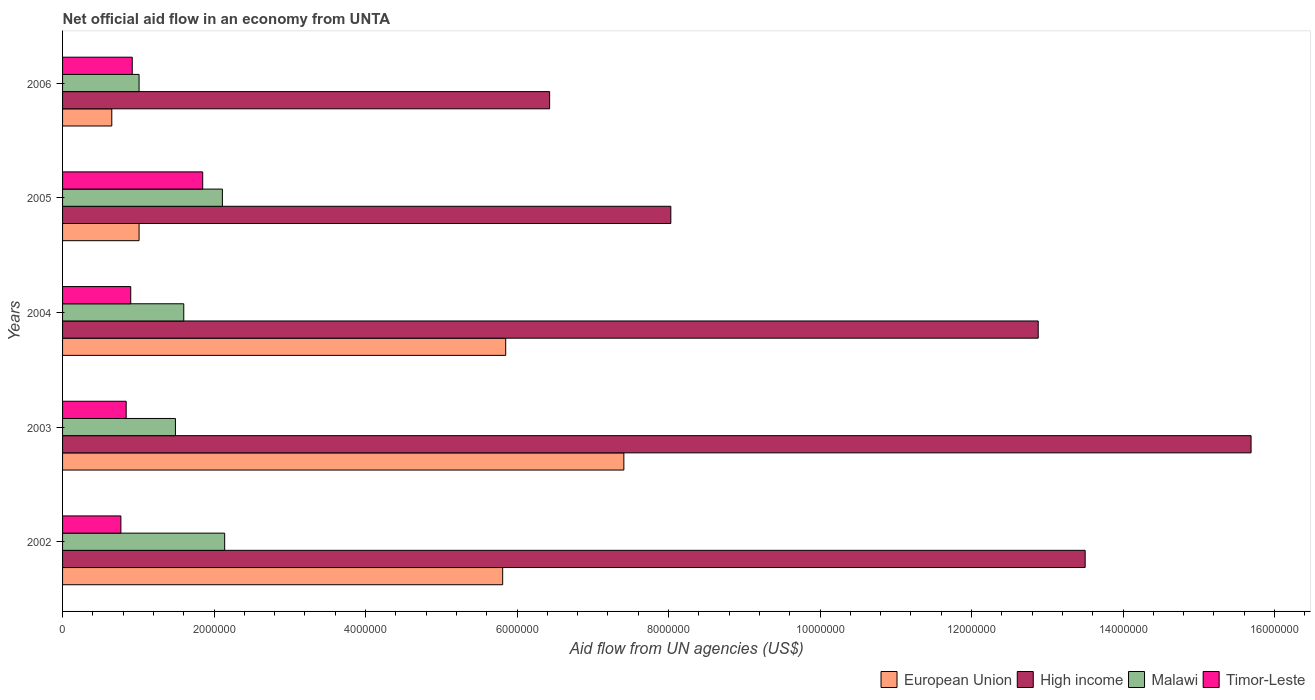How many groups of bars are there?
Make the answer very short. 5. How many bars are there on the 5th tick from the top?
Ensure brevity in your answer.  4. What is the label of the 5th group of bars from the top?
Provide a short and direct response. 2002. What is the net official aid flow in European Union in 2002?
Make the answer very short. 5.81e+06. Across all years, what is the maximum net official aid flow in Timor-Leste?
Ensure brevity in your answer.  1.85e+06. Across all years, what is the minimum net official aid flow in European Union?
Your response must be concise. 6.50e+05. What is the total net official aid flow in Timor-Leste in the graph?
Keep it short and to the point. 5.28e+06. What is the difference between the net official aid flow in European Union in 2002 and that in 2005?
Give a very brief answer. 4.80e+06. What is the difference between the net official aid flow in High income in 2005 and the net official aid flow in Malawi in 2002?
Provide a succinct answer. 5.89e+06. What is the average net official aid flow in High income per year?
Provide a succinct answer. 1.13e+07. In the year 2005, what is the difference between the net official aid flow in High income and net official aid flow in European Union?
Ensure brevity in your answer.  7.02e+06. What is the ratio of the net official aid flow in Malawi in 2003 to that in 2004?
Offer a very short reply. 0.93. Is the net official aid flow in Timor-Leste in 2003 less than that in 2005?
Your answer should be compact. Yes. What is the difference between the highest and the second highest net official aid flow in Timor-Leste?
Provide a short and direct response. 9.30e+05. What is the difference between the highest and the lowest net official aid flow in European Union?
Provide a succinct answer. 6.76e+06. In how many years, is the net official aid flow in High income greater than the average net official aid flow in High income taken over all years?
Give a very brief answer. 3. Is the sum of the net official aid flow in High income in 2002 and 2004 greater than the maximum net official aid flow in Malawi across all years?
Provide a succinct answer. Yes. Is it the case that in every year, the sum of the net official aid flow in High income and net official aid flow in Timor-Leste is greater than the net official aid flow in Malawi?
Your answer should be compact. Yes. Are the values on the major ticks of X-axis written in scientific E-notation?
Make the answer very short. No. What is the title of the graph?
Keep it short and to the point. Net official aid flow in an economy from UNTA. What is the label or title of the X-axis?
Your answer should be compact. Aid flow from UN agencies (US$). What is the Aid flow from UN agencies (US$) of European Union in 2002?
Give a very brief answer. 5.81e+06. What is the Aid flow from UN agencies (US$) of High income in 2002?
Provide a succinct answer. 1.35e+07. What is the Aid flow from UN agencies (US$) in Malawi in 2002?
Your response must be concise. 2.14e+06. What is the Aid flow from UN agencies (US$) of Timor-Leste in 2002?
Provide a succinct answer. 7.70e+05. What is the Aid flow from UN agencies (US$) in European Union in 2003?
Ensure brevity in your answer.  7.41e+06. What is the Aid flow from UN agencies (US$) in High income in 2003?
Your response must be concise. 1.57e+07. What is the Aid flow from UN agencies (US$) of Malawi in 2003?
Ensure brevity in your answer.  1.49e+06. What is the Aid flow from UN agencies (US$) in Timor-Leste in 2003?
Make the answer very short. 8.40e+05. What is the Aid flow from UN agencies (US$) in European Union in 2004?
Provide a short and direct response. 5.85e+06. What is the Aid flow from UN agencies (US$) of High income in 2004?
Give a very brief answer. 1.29e+07. What is the Aid flow from UN agencies (US$) of Malawi in 2004?
Make the answer very short. 1.60e+06. What is the Aid flow from UN agencies (US$) in Timor-Leste in 2004?
Offer a terse response. 9.00e+05. What is the Aid flow from UN agencies (US$) of European Union in 2005?
Provide a succinct answer. 1.01e+06. What is the Aid flow from UN agencies (US$) in High income in 2005?
Provide a short and direct response. 8.03e+06. What is the Aid flow from UN agencies (US$) of Malawi in 2005?
Provide a short and direct response. 2.11e+06. What is the Aid flow from UN agencies (US$) of Timor-Leste in 2005?
Your answer should be compact. 1.85e+06. What is the Aid flow from UN agencies (US$) of European Union in 2006?
Make the answer very short. 6.50e+05. What is the Aid flow from UN agencies (US$) in High income in 2006?
Provide a succinct answer. 6.43e+06. What is the Aid flow from UN agencies (US$) in Malawi in 2006?
Make the answer very short. 1.01e+06. What is the Aid flow from UN agencies (US$) in Timor-Leste in 2006?
Offer a very short reply. 9.20e+05. Across all years, what is the maximum Aid flow from UN agencies (US$) in European Union?
Your answer should be compact. 7.41e+06. Across all years, what is the maximum Aid flow from UN agencies (US$) of High income?
Provide a succinct answer. 1.57e+07. Across all years, what is the maximum Aid flow from UN agencies (US$) of Malawi?
Keep it short and to the point. 2.14e+06. Across all years, what is the maximum Aid flow from UN agencies (US$) in Timor-Leste?
Offer a very short reply. 1.85e+06. Across all years, what is the minimum Aid flow from UN agencies (US$) of European Union?
Offer a very short reply. 6.50e+05. Across all years, what is the minimum Aid flow from UN agencies (US$) of High income?
Provide a short and direct response. 6.43e+06. Across all years, what is the minimum Aid flow from UN agencies (US$) of Malawi?
Offer a terse response. 1.01e+06. Across all years, what is the minimum Aid flow from UN agencies (US$) of Timor-Leste?
Give a very brief answer. 7.70e+05. What is the total Aid flow from UN agencies (US$) in European Union in the graph?
Ensure brevity in your answer.  2.07e+07. What is the total Aid flow from UN agencies (US$) in High income in the graph?
Ensure brevity in your answer.  5.65e+07. What is the total Aid flow from UN agencies (US$) in Malawi in the graph?
Provide a succinct answer. 8.35e+06. What is the total Aid flow from UN agencies (US$) of Timor-Leste in the graph?
Give a very brief answer. 5.28e+06. What is the difference between the Aid flow from UN agencies (US$) in European Union in 2002 and that in 2003?
Provide a succinct answer. -1.60e+06. What is the difference between the Aid flow from UN agencies (US$) in High income in 2002 and that in 2003?
Your response must be concise. -2.19e+06. What is the difference between the Aid flow from UN agencies (US$) in Malawi in 2002 and that in 2003?
Make the answer very short. 6.50e+05. What is the difference between the Aid flow from UN agencies (US$) of European Union in 2002 and that in 2004?
Your answer should be compact. -4.00e+04. What is the difference between the Aid flow from UN agencies (US$) of High income in 2002 and that in 2004?
Keep it short and to the point. 6.20e+05. What is the difference between the Aid flow from UN agencies (US$) in Malawi in 2002 and that in 2004?
Make the answer very short. 5.40e+05. What is the difference between the Aid flow from UN agencies (US$) in Timor-Leste in 2002 and that in 2004?
Your response must be concise. -1.30e+05. What is the difference between the Aid flow from UN agencies (US$) of European Union in 2002 and that in 2005?
Your response must be concise. 4.80e+06. What is the difference between the Aid flow from UN agencies (US$) of High income in 2002 and that in 2005?
Ensure brevity in your answer.  5.47e+06. What is the difference between the Aid flow from UN agencies (US$) of Timor-Leste in 2002 and that in 2005?
Make the answer very short. -1.08e+06. What is the difference between the Aid flow from UN agencies (US$) of European Union in 2002 and that in 2006?
Provide a short and direct response. 5.16e+06. What is the difference between the Aid flow from UN agencies (US$) of High income in 2002 and that in 2006?
Provide a succinct answer. 7.07e+06. What is the difference between the Aid flow from UN agencies (US$) of Malawi in 2002 and that in 2006?
Offer a very short reply. 1.13e+06. What is the difference between the Aid flow from UN agencies (US$) in European Union in 2003 and that in 2004?
Your response must be concise. 1.56e+06. What is the difference between the Aid flow from UN agencies (US$) in High income in 2003 and that in 2004?
Ensure brevity in your answer.  2.81e+06. What is the difference between the Aid flow from UN agencies (US$) of European Union in 2003 and that in 2005?
Keep it short and to the point. 6.40e+06. What is the difference between the Aid flow from UN agencies (US$) of High income in 2003 and that in 2005?
Offer a terse response. 7.66e+06. What is the difference between the Aid flow from UN agencies (US$) of Malawi in 2003 and that in 2005?
Your answer should be very brief. -6.20e+05. What is the difference between the Aid flow from UN agencies (US$) in Timor-Leste in 2003 and that in 2005?
Offer a very short reply. -1.01e+06. What is the difference between the Aid flow from UN agencies (US$) in European Union in 2003 and that in 2006?
Give a very brief answer. 6.76e+06. What is the difference between the Aid flow from UN agencies (US$) in High income in 2003 and that in 2006?
Your answer should be compact. 9.26e+06. What is the difference between the Aid flow from UN agencies (US$) of Malawi in 2003 and that in 2006?
Provide a succinct answer. 4.80e+05. What is the difference between the Aid flow from UN agencies (US$) of Timor-Leste in 2003 and that in 2006?
Make the answer very short. -8.00e+04. What is the difference between the Aid flow from UN agencies (US$) of European Union in 2004 and that in 2005?
Provide a short and direct response. 4.84e+06. What is the difference between the Aid flow from UN agencies (US$) in High income in 2004 and that in 2005?
Your answer should be compact. 4.85e+06. What is the difference between the Aid flow from UN agencies (US$) in Malawi in 2004 and that in 2005?
Ensure brevity in your answer.  -5.10e+05. What is the difference between the Aid flow from UN agencies (US$) in Timor-Leste in 2004 and that in 2005?
Ensure brevity in your answer.  -9.50e+05. What is the difference between the Aid flow from UN agencies (US$) of European Union in 2004 and that in 2006?
Ensure brevity in your answer.  5.20e+06. What is the difference between the Aid flow from UN agencies (US$) of High income in 2004 and that in 2006?
Your response must be concise. 6.45e+06. What is the difference between the Aid flow from UN agencies (US$) in Malawi in 2004 and that in 2006?
Give a very brief answer. 5.90e+05. What is the difference between the Aid flow from UN agencies (US$) in European Union in 2005 and that in 2006?
Keep it short and to the point. 3.60e+05. What is the difference between the Aid flow from UN agencies (US$) in High income in 2005 and that in 2006?
Your response must be concise. 1.60e+06. What is the difference between the Aid flow from UN agencies (US$) in Malawi in 2005 and that in 2006?
Provide a succinct answer. 1.10e+06. What is the difference between the Aid flow from UN agencies (US$) of Timor-Leste in 2005 and that in 2006?
Your answer should be compact. 9.30e+05. What is the difference between the Aid flow from UN agencies (US$) of European Union in 2002 and the Aid flow from UN agencies (US$) of High income in 2003?
Your answer should be compact. -9.88e+06. What is the difference between the Aid flow from UN agencies (US$) of European Union in 2002 and the Aid flow from UN agencies (US$) of Malawi in 2003?
Provide a succinct answer. 4.32e+06. What is the difference between the Aid flow from UN agencies (US$) of European Union in 2002 and the Aid flow from UN agencies (US$) of Timor-Leste in 2003?
Provide a succinct answer. 4.97e+06. What is the difference between the Aid flow from UN agencies (US$) in High income in 2002 and the Aid flow from UN agencies (US$) in Malawi in 2003?
Give a very brief answer. 1.20e+07. What is the difference between the Aid flow from UN agencies (US$) of High income in 2002 and the Aid flow from UN agencies (US$) of Timor-Leste in 2003?
Offer a terse response. 1.27e+07. What is the difference between the Aid flow from UN agencies (US$) of Malawi in 2002 and the Aid flow from UN agencies (US$) of Timor-Leste in 2003?
Make the answer very short. 1.30e+06. What is the difference between the Aid flow from UN agencies (US$) in European Union in 2002 and the Aid flow from UN agencies (US$) in High income in 2004?
Offer a very short reply. -7.07e+06. What is the difference between the Aid flow from UN agencies (US$) in European Union in 2002 and the Aid flow from UN agencies (US$) in Malawi in 2004?
Give a very brief answer. 4.21e+06. What is the difference between the Aid flow from UN agencies (US$) in European Union in 2002 and the Aid flow from UN agencies (US$) in Timor-Leste in 2004?
Your answer should be compact. 4.91e+06. What is the difference between the Aid flow from UN agencies (US$) of High income in 2002 and the Aid flow from UN agencies (US$) of Malawi in 2004?
Provide a succinct answer. 1.19e+07. What is the difference between the Aid flow from UN agencies (US$) of High income in 2002 and the Aid flow from UN agencies (US$) of Timor-Leste in 2004?
Offer a terse response. 1.26e+07. What is the difference between the Aid flow from UN agencies (US$) in Malawi in 2002 and the Aid flow from UN agencies (US$) in Timor-Leste in 2004?
Provide a succinct answer. 1.24e+06. What is the difference between the Aid flow from UN agencies (US$) in European Union in 2002 and the Aid flow from UN agencies (US$) in High income in 2005?
Provide a short and direct response. -2.22e+06. What is the difference between the Aid flow from UN agencies (US$) of European Union in 2002 and the Aid flow from UN agencies (US$) of Malawi in 2005?
Make the answer very short. 3.70e+06. What is the difference between the Aid flow from UN agencies (US$) of European Union in 2002 and the Aid flow from UN agencies (US$) of Timor-Leste in 2005?
Offer a very short reply. 3.96e+06. What is the difference between the Aid flow from UN agencies (US$) of High income in 2002 and the Aid flow from UN agencies (US$) of Malawi in 2005?
Your response must be concise. 1.14e+07. What is the difference between the Aid flow from UN agencies (US$) of High income in 2002 and the Aid flow from UN agencies (US$) of Timor-Leste in 2005?
Provide a succinct answer. 1.16e+07. What is the difference between the Aid flow from UN agencies (US$) of European Union in 2002 and the Aid flow from UN agencies (US$) of High income in 2006?
Offer a very short reply. -6.20e+05. What is the difference between the Aid flow from UN agencies (US$) of European Union in 2002 and the Aid flow from UN agencies (US$) of Malawi in 2006?
Offer a terse response. 4.80e+06. What is the difference between the Aid flow from UN agencies (US$) in European Union in 2002 and the Aid flow from UN agencies (US$) in Timor-Leste in 2006?
Offer a terse response. 4.89e+06. What is the difference between the Aid flow from UN agencies (US$) in High income in 2002 and the Aid flow from UN agencies (US$) in Malawi in 2006?
Your answer should be very brief. 1.25e+07. What is the difference between the Aid flow from UN agencies (US$) of High income in 2002 and the Aid flow from UN agencies (US$) of Timor-Leste in 2006?
Provide a succinct answer. 1.26e+07. What is the difference between the Aid flow from UN agencies (US$) of Malawi in 2002 and the Aid flow from UN agencies (US$) of Timor-Leste in 2006?
Your response must be concise. 1.22e+06. What is the difference between the Aid flow from UN agencies (US$) of European Union in 2003 and the Aid flow from UN agencies (US$) of High income in 2004?
Offer a very short reply. -5.47e+06. What is the difference between the Aid flow from UN agencies (US$) in European Union in 2003 and the Aid flow from UN agencies (US$) in Malawi in 2004?
Your answer should be very brief. 5.81e+06. What is the difference between the Aid flow from UN agencies (US$) in European Union in 2003 and the Aid flow from UN agencies (US$) in Timor-Leste in 2004?
Make the answer very short. 6.51e+06. What is the difference between the Aid flow from UN agencies (US$) in High income in 2003 and the Aid flow from UN agencies (US$) in Malawi in 2004?
Your response must be concise. 1.41e+07. What is the difference between the Aid flow from UN agencies (US$) of High income in 2003 and the Aid flow from UN agencies (US$) of Timor-Leste in 2004?
Offer a very short reply. 1.48e+07. What is the difference between the Aid flow from UN agencies (US$) in Malawi in 2003 and the Aid flow from UN agencies (US$) in Timor-Leste in 2004?
Offer a terse response. 5.90e+05. What is the difference between the Aid flow from UN agencies (US$) of European Union in 2003 and the Aid flow from UN agencies (US$) of High income in 2005?
Provide a succinct answer. -6.20e+05. What is the difference between the Aid flow from UN agencies (US$) in European Union in 2003 and the Aid flow from UN agencies (US$) in Malawi in 2005?
Provide a short and direct response. 5.30e+06. What is the difference between the Aid flow from UN agencies (US$) in European Union in 2003 and the Aid flow from UN agencies (US$) in Timor-Leste in 2005?
Provide a short and direct response. 5.56e+06. What is the difference between the Aid flow from UN agencies (US$) of High income in 2003 and the Aid flow from UN agencies (US$) of Malawi in 2005?
Offer a terse response. 1.36e+07. What is the difference between the Aid flow from UN agencies (US$) in High income in 2003 and the Aid flow from UN agencies (US$) in Timor-Leste in 2005?
Provide a succinct answer. 1.38e+07. What is the difference between the Aid flow from UN agencies (US$) in Malawi in 2003 and the Aid flow from UN agencies (US$) in Timor-Leste in 2005?
Give a very brief answer. -3.60e+05. What is the difference between the Aid flow from UN agencies (US$) in European Union in 2003 and the Aid flow from UN agencies (US$) in High income in 2006?
Your response must be concise. 9.80e+05. What is the difference between the Aid flow from UN agencies (US$) in European Union in 2003 and the Aid flow from UN agencies (US$) in Malawi in 2006?
Offer a terse response. 6.40e+06. What is the difference between the Aid flow from UN agencies (US$) in European Union in 2003 and the Aid flow from UN agencies (US$) in Timor-Leste in 2006?
Your answer should be compact. 6.49e+06. What is the difference between the Aid flow from UN agencies (US$) of High income in 2003 and the Aid flow from UN agencies (US$) of Malawi in 2006?
Give a very brief answer. 1.47e+07. What is the difference between the Aid flow from UN agencies (US$) of High income in 2003 and the Aid flow from UN agencies (US$) of Timor-Leste in 2006?
Provide a succinct answer. 1.48e+07. What is the difference between the Aid flow from UN agencies (US$) of Malawi in 2003 and the Aid flow from UN agencies (US$) of Timor-Leste in 2006?
Make the answer very short. 5.70e+05. What is the difference between the Aid flow from UN agencies (US$) of European Union in 2004 and the Aid flow from UN agencies (US$) of High income in 2005?
Give a very brief answer. -2.18e+06. What is the difference between the Aid flow from UN agencies (US$) in European Union in 2004 and the Aid flow from UN agencies (US$) in Malawi in 2005?
Offer a terse response. 3.74e+06. What is the difference between the Aid flow from UN agencies (US$) in High income in 2004 and the Aid flow from UN agencies (US$) in Malawi in 2005?
Your response must be concise. 1.08e+07. What is the difference between the Aid flow from UN agencies (US$) of High income in 2004 and the Aid flow from UN agencies (US$) of Timor-Leste in 2005?
Make the answer very short. 1.10e+07. What is the difference between the Aid flow from UN agencies (US$) of Malawi in 2004 and the Aid flow from UN agencies (US$) of Timor-Leste in 2005?
Provide a short and direct response. -2.50e+05. What is the difference between the Aid flow from UN agencies (US$) in European Union in 2004 and the Aid flow from UN agencies (US$) in High income in 2006?
Provide a succinct answer. -5.80e+05. What is the difference between the Aid flow from UN agencies (US$) of European Union in 2004 and the Aid flow from UN agencies (US$) of Malawi in 2006?
Give a very brief answer. 4.84e+06. What is the difference between the Aid flow from UN agencies (US$) of European Union in 2004 and the Aid flow from UN agencies (US$) of Timor-Leste in 2006?
Ensure brevity in your answer.  4.93e+06. What is the difference between the Aid flow from UN agencies (US$) of High income in 2004 and the Aid flow from UN agencies (US$) of Malawi in 2006?
Ensure brevity in your answer.  1.19e+07. What is the difference between the Aid flow from UN agencies (US$) of High income in 2004 and the Aid flow from UN agencies (US$) of Timor-Leste in 2006?
Offer a very short reply. 1.20e+07. What is the difference between the Aid flow from UN agencies (US$) in Malawi in 2004 and the Aid flow from UN agencies (US$) in Timor-Leste in 2006?
Give a very brief answer. 6.80e+05. What is the difference between the Aid flow from UN agencies (US$) in European Union in 2005 and the Aid flow from UN agencies (US$) in High income in 2006?
Offer a very short reply. -5.42e+06. What is the difference between the Aid flow from UN agencies (US$) in European Union in 2005 and the Aid flow from UN agencies (US$) in Malawi in 2006?
Your answer should be compact. 0. What is the difference between the Aid flow from UN agencies (US$) in European Union in 2005 and the Aid flow from UN agencies (US$) in Timor-Leste in 2006?
Keep it short and to the point. 9.00e+04. What is the difference between the Aid flow from UN agencies (US$) of High income in 2005 and the Aid flow from UN agencies (US$) of Malawi in 2006?
Keep it short and to the point. 7.02e+06. What is the difference between the Aid flow from UN agencies (US$) in High income in 2005 and the Aid flow from UN agencies (US$) in Timor-Leste in 2006?
Make the answer very short. 7.11e+06. What is the difference between the Aid flow from UN agencies (US$) of Malawi in 2005 and the Aid flow from UN agencies (US$) of Timor-Leste in 2006?
Keep it short and to the point. 1.19e+06. What is the average Aid flow from UN agencies (US$) in European Union per year?
Keep it short and to the point. 4.15e+06. What is the average Aid flow from UN agencies (US$) in High income per year?
Make the answer very short. 1.13e+07. What is the average Aid flow from UN agencies (US$) of Malawi per year?
Your response must be concise. 1.67e+06. What is the average Aid flow from UN agencies (US$) of Timor-Leste per year?
Ensure brevity in your answer.  1.06e+06. In the year 2002, what is the difference between the Aid flow from UN agencies (US$) of European Union and Aid flow from UN agencies (US$) of High income?
Make the answer very short. -7.69e+06. In the year 2002, what is the difference between the Aid flow from UN agencies (US$) in European Union and Aid flow from UN agencies (US$) in Malawi?
Offer a terse response. 3.67e+06. In the year 2002, what is the difference between the Aid flow from UN agencies (US$) of European Union and Aid flow from UN agencies (US$) of Timor-Leste?
Offer a terse response. 5.04e+06. In the year 2002, what is the difference between the Aid flow from UN agencies (US$) in High income and Aid flow from UN agencies (US$) in Malawi?
Give a very brief answer. 1.14e+07. In the year 2002, what is the difference between the Aid flow from UN agencies (US$) in High income and Aid flow from UN agencies (US$) in Timor-Leste?
Offer a very short reply. 1.27e+07. In the year 2002, what is the difference between the Aid flow from UN agencies (US$) of Malawi and Aid flow from UN agencies (US$) of Timor-Leste?
Offer a terse response. 1.37e+06. In the year 2003, what is the difference between the Aid flow from UN agencies (US$) in European Union and Aid flow from UN agencies (US$) in High income?
Your answer should be compact. -8.28e+06. In the year 2003, what is the difference between the Aid flow from UN agencies (US$) in European Union and Aid flow from UN agencies (US$) in Malawi?
Make the answer very short. 5.92e+06. In the year 2003, what is the difference between the Aid flow from UN agencies (US$) in European Union and Aid flow from UN agencies (US$) in Timor-Leste?
Give a very brief answer. 6.57e+06. In the year 2003, what is the difference between the Aid flow from UN agencies (US$) in High income and Aid flow from UN agencies (US$) in Malawi?
Give a very brief answer. 1.42e+07. In the year 2003, what is the difference between the Aid flow from UN agencies (US$) in High income and Aid flow from UN agencies (US$) in Timor-Leste?
Provide a succinct answer. 1.48e+07. In the year 2003, what is the difference between the Aid flow from UN agencies (US$) in Malawi and Aid flow from UN agencies (US$) in Timor-Leste?
Offer a very short reply. 6.50e+05. In the year 2004, what is the difference between the Aid flow from UN agencies (US$) of European Union and Aid flow from UN agencies (US$) of High income?
Offer a terse response. -7.03e+06. In the year 2004, what is the difference between the Aid flow from UN agencies (US$) of European Union and Aid flow from UN agencies (US$) of Malawi?
Provide a succinct answer. 4.25e+06. In the year 2004, what is the difference between the Aid flow from UN agencies (US$) in European Union and Aid flow from UN agencies (US$) in Timor-Leste?
Your answer should be compact. 4.95e+06. In the year 2004, what is the difference between the Aid flow from UN agencies (US$) of High income and Aid flow from UN agencies (US$) of Malawi?
Provide a short and direct response. 1.13e+07. In the year 2004, what is the difference between the Aid flow from UN agencies (US$) of High income and Aid flow from UN agencies (US$) of Timor-Leste?
Make the answer very short. 1.20e+07. In the year 2004, what is the difference between the Aid flow from UN agencies (US$) of Malawi and Aid flow from UN agencies (US$) of Timor-Leste?
Provide a short and direct response. 7.00e+05. In the year 2005, what is the difference between the Aid flow from UN agencies (US$) of European Union and Aid flow from UN agencies (US$) of High income?
Your answer should be compact. -7.02e+06. In the year 2005, what is the difference between the Aid flow from UN agencies (US$) in European Union and Aid flow from UN agencies (US$) in Malawi?
Your answer should be compact. -1.10e+06. In the year 2005, what is the difference between the Aid flow from UN agencies (US$) of European Union and Aid flow from UN agencies (US$) of Timor-Leste?
Your answer should be compact. -8.40e+05. In the year 2005, what is the difference between the Aid flow from UN agencies (US$) of High income and Aid flow from UN agencies (US$) of Malawi?
Make the answer very short. 5.92e+06. In the year 2005, what is the difference between the Aid flow from UN agencies (US$) of High income and Aid flow from UN agencies (US$) of Timor-Leste?
Your answer should be compact. 6.18e+06. In the year 2006, what is the difference between the Aid flow from UN agencies (US$) of European Union and Aid flow from UN agencies (US$) of High income?
Make the answer very short. -5.78e+06. In the year 2006, what is the difference between the Aid flow from UN agencies (US$) of European Union and Aid flow from UN agencies (US$) of Malawi?
Provide a short and direct response. -3.60e+05. In the year 2006, what is the difference between the Aid flow from UN agencies (US$) of European Union and Aid flow from UN agencies (US$) of Timor-Leste?
Offer a very short reply. -2.70e+05. In the year 2006, what is the difference between the Aid flow from UN agencies (US$) of High income and Aid flow from UN agencies (US$) of Malawi?
Your answer should be very brief. 5.42e+06. In the year 2006, what is the difference between the Aid flow from UN agencies (US$) in High income and Aid flow from UN agencies (US$) in Timor-Leste?
Provide a succinct answer. 5.51e+06. In the year 2006, what is the difference between the Aid flow from UN agencies (US$) of Malawi and Aid flow from UN agencies (US$) of Timor-Leste?
Ensure brevity in your answer.  9.00e+04. What is the ratio of the Aid flow from UN agencies (US$) in European Union in 2002 to that in 2003?
Your response must be concise. 0.78. What is the ratio of the Aid flow from UN agencies (US$) in High income in 2002 to that in 2003?
Your response must be concise. 0.86. What is the ratio of the Aid flow from UN agencies (US$) in Malawi in 2002 to that in 2003?
Keep it short and to the point. 1.44. What is the ratio of the Aid flow from UN agencies (US$) of High income in 2002 to that in 2004?
Your answer should be very brief. 1.05. What is the ratio of the Aid flow from UN agencies (US$) of Malawi in 2002 to that in 2004?
Keep it short and to the point. 1.34. What is the ratio of the Aid flow from UN agencies (US$) in Timor-Leste in 2002 to that in 2004?
Give a very brief answer. 0.86. What is the ratio of the Aid flow from UN agencies (US$) in European Union in 2002 to that in 2005?
Your response must be concise. 5.75. What is the ratio of the Aid flow from UN agencies (US$) of High income in 2002 to that in 2005?
Make the answer very short. 1.68. What is the ratio of the Aid flow from UN agencies (US$) in Malawi in 2002 to that in 2005?
Ensure brevity in your answer.  1.01. What is the ratio of the Aid flow from UN agencies (US$) of Timor-Leste in 2002 to that in 2005?
Give a very brief answer. 0.42. What is the ratio of the Aid flow from UN agencies (US$) of European Union in 2002 to that in 2006?
Ensure brevity in your answer.  8.94. What is the ratio of the Aid flow from UN agencies (US$) in High income in 2002 to that in 2006?
Offer a very short reply. 2.1. What is the ratio of the Aid flow from UN agencies (US$) in Malawi in 2002 to that in 2006?
Your answer should be very brief. 2.12. What is the ratio of the Aid flow from UN agencies (US$) of Timor-Leste in 2002 to that in 2006?
Your response must be concise. 0.84. What is the ratio of the Aid flow from UN agencies (US$) of European Union in 2003 to that in 2004?
Keep it short and to the point. 1.27. What is the ratio of the Aid flow from UN agencies (US$) of High income in 2003 to that in 2004?
Offer a very short reply. 1.22. What is the ratio of the Aid flow from UN agencies (US$) of Malawi in 2003 to that in 2004?
Give a very brief answer. 0.93. What is the ratio of the Aid flow from UN agencies (US$) in Timor-Leste in 2003 to that in 2004?
Give a very brief answer. 0.93. What is the ratio of the Aid flow from UN agencies (US$) in European Union in 2003 to that in 2005?
Offer a terse response. 7.34. What is the ratio of the Aid flow from UN agencies (US$) in High income in 2003 to that in 2005?
Provide a succinct answer. 1.95. What is the ratio of the Aid flow from UN agencies (US$) in Malawi in 2003 to that in 2005?
Provide a succinct answer. 0.71. What is the ratio of the Aid flow from UN agencies (US$) of Timor-Leste in 2003 to that in 2005?
Give a very brief answer. 0.45. What is the ratio of the Aid flow from UN agencies (US$) of High income in 2003 to that in 2006?
Your answer should be compact. 2.44. What is the ratio of the Aid flow from UN agencies (US$) in Malawi in 2003 to that in 2006?
Give a very brief answer. 1.48. What is the ratio of the Aid flow from UN agencies (US$) of European Union in 2004 to that in 2005?
Your response must be concise. 5.79. What is the ratio of the Aid flow from UN agencies (US$) of High income in 2004 to that in 2005?
Your answer should be compact. 1.6. What is the ratio of the Aid flow from UN agencies (US$) of Malawi in 2004 to that in 2005?
Make the answer very short. 0.76. What is the ratio of the Aid flow from UN agencies (US$) of Timor-Leste in 2004 to that in 2005?
Offer a very short reply. 0.49. What is the ratio of the Aid flow from UN agencies (US$) in High income in 2004 to that in 2006?
Your response must be concise. 2. What is the ratio of the Aid flow from UN agencies (US$) of Malawi in 2004 to that in 2006?
Keep it short and to the point. 1.58. What is the ratio of the Aid flow from UN agencies (US$) of Timor-Leste in 2004 to that in 2006?
Ensure brevity in your answer.  0.98. What is the ratio of the Aid flow from UN agencies (US$) in European Union in 2005 to that in 2006?
Provide a short and direct response. 1.55. What is the ratio of the Aid flow from UN agencies (US$) of High income in 2005 to that in 2006?
Your answer should be very brief. 1.25. What is the ratio of the Aid flow from UN agencies (US$) of Malawi in 2005 to that in 2006?
Offer a terse response. 2.09. What is the ratio of the Aid flow from UN agencies (US$) of Timor-Leste in 2005 to that in 2006?
Provide a short and direct response. 2.01. What is the difference between the highest and the second highest Aid flow from UN agencies (US$) in European Union?
Provide a short and direct response. 1.56e+06. What is the difference between the highest and the second highest Aid flow from UN agencies (US$) of High income?
Keep it short and to the point. 2.19e+06. What is the difference between the highest and the second highest Aid flow from UN agencies (US$) of Timor-Leste?
Ensure brevity in your answer.  9.30e+05. What is the difference between the highest and the lowest Aid flow from UN agencies (US$) of European Union?
Provide a short and direct response. 6.76e+06. What is the difference between the highest and the lowest Aid flow from UN agencies (US$) in High income?
Keep it short and to the point. 9.26e+06. What is the difference between the highest and the lowest Aid flow from UN agencies (US$) in Malawi?
Your response must be concise. 1.13e+06. What is the difference between the highest and the lowest Aid flow from UN agencies (US$) in Timor-Leste?
Ensure brevity in your answer.  1.08e+06. 